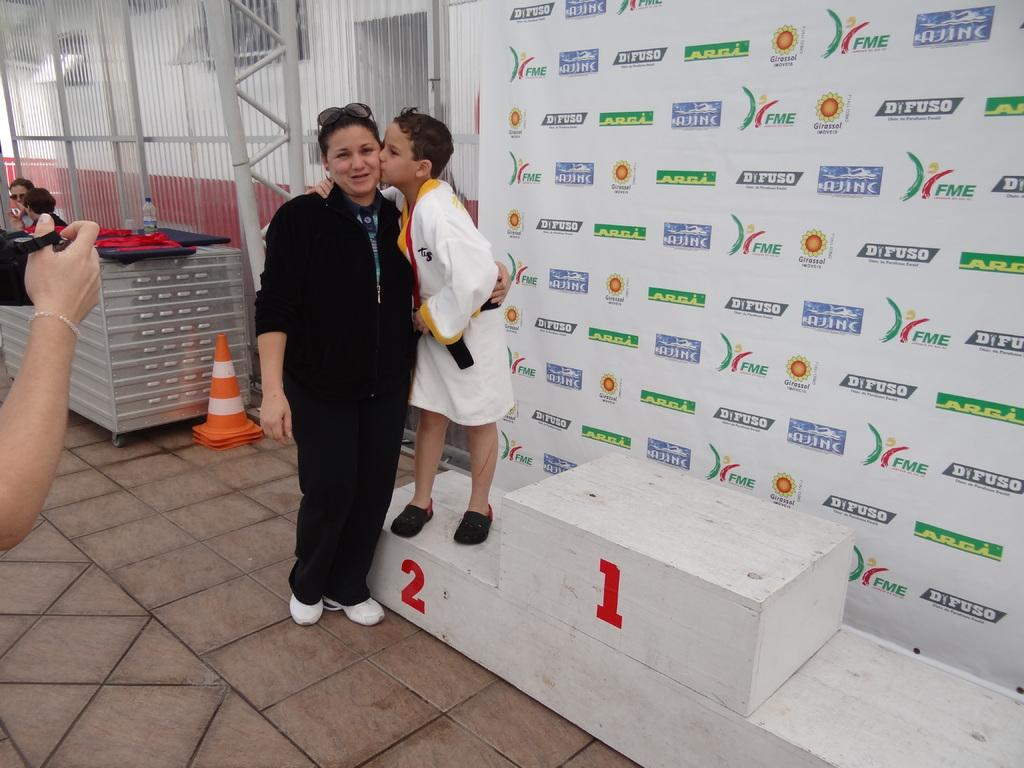How many people are in the image? There are people in the image, but the exact number cannot be determined from the provided facts. What type of structure is in the image? There is a wooden stand in the image. What is the purpose of the traffic cone in the image? The purpose of the traffic cone in the image is not clear from the provided facts. What is the bottle in the image used for? The purpose of the bottle in the image is not clear from the provided facts. What is the floor made of in the image? The floor is visible in the image, but its material is not mentioned in the provided facts. What are the poles used for in the image? The purpose of the poles in the image is not clear from the provided facts. What is the wall made of in the image? The material of the wall in the image is not mentioned in the provided facts. What does the banner say in the image? The message on the banner in the image is not mentioned in the provided facts. What type of cake is being served on the dock in the image? There is no dock or cake present in the image. How many earths can be seen in the image? There is no earth visible in the image; only the wooden stand, traffic cone, bottle, floor, poles, wall, and banner are present. 